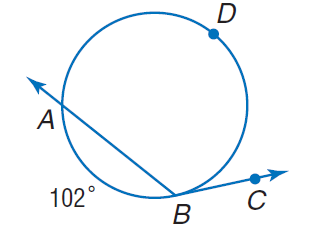Answer the mathemtical geometry problem and directly provide the correct option letter.
Question: Find m \angle A B C if m \widehat A B = 102.
Choices: A: 102 B: 129 C: 204 D: 306 B 